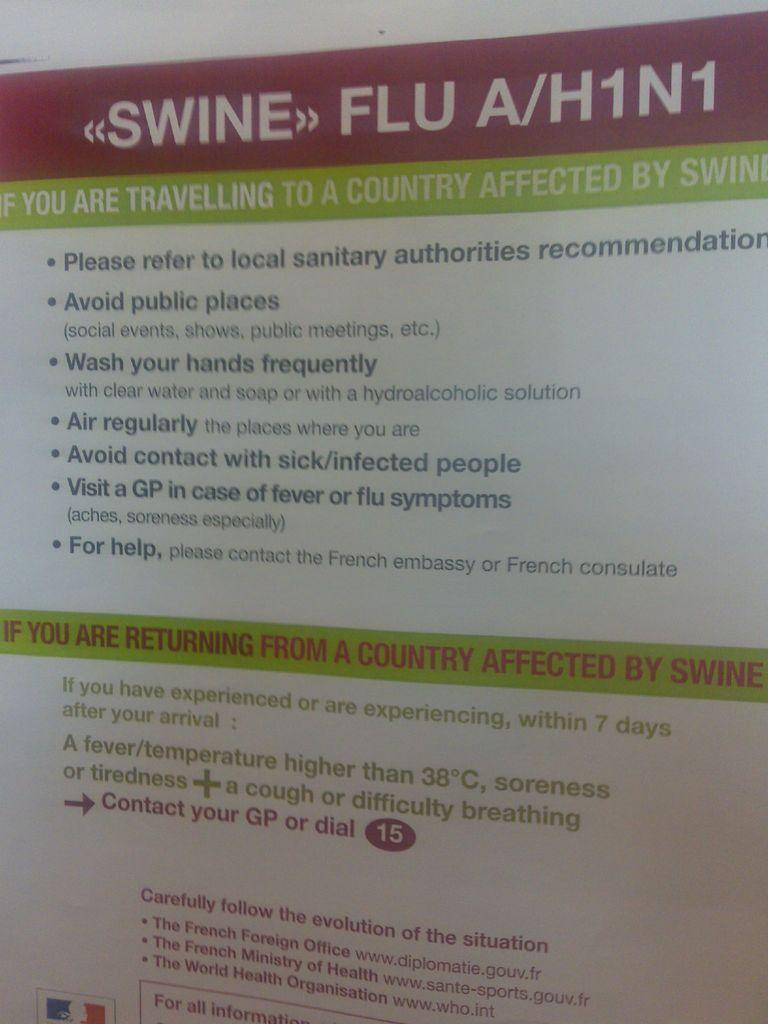<image>
Present a compact description of the photo's key features. a piece of paper that talks about swine flu 